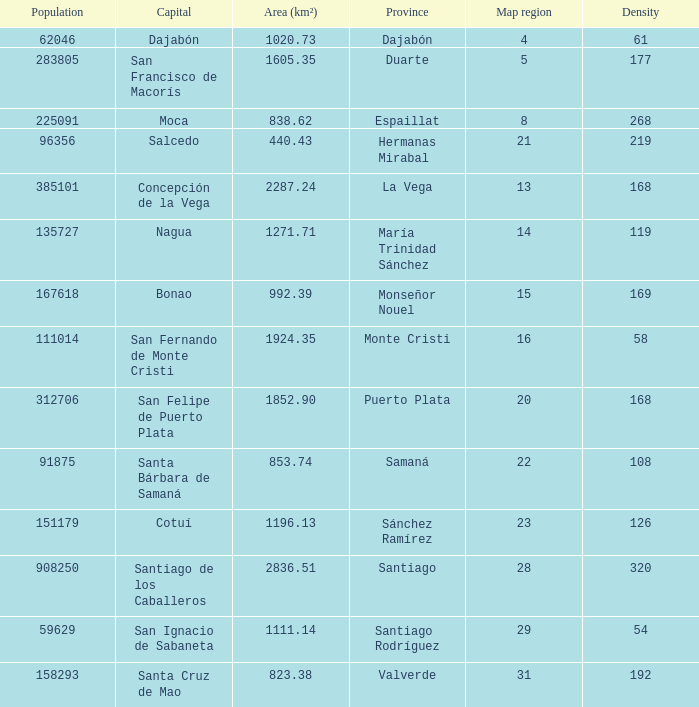When province is monseñor nouel, what is the area (km²)? 992.39. 